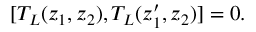Convert formula to latex. <formula><loc_0><loc_0><loc_500><loc_500>[ T _ { L } ( z _ { 1 } , z _ { 2 } ) , T _ { L } ( z _ { 1 } ^ { \prime } , z _ { 2 } ) ] = 0 .</formula> 